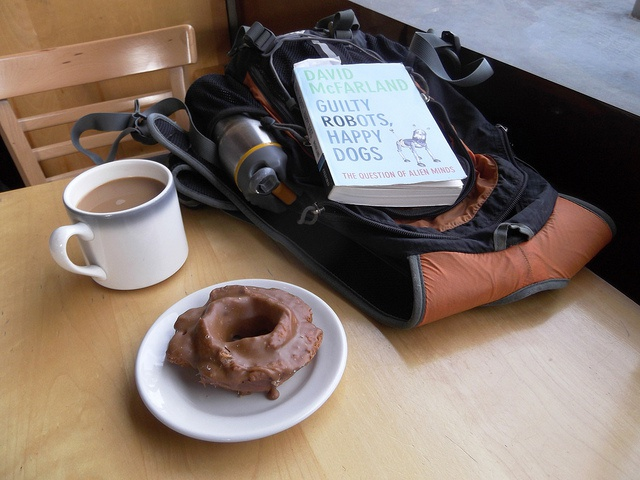Describe the objects in this image and their specific colors. I can see dining table in olive, lightgray, tan, gray, and darkgray tones, backpack in olive, black, brown, gray, and maroon tones, book in olive, lightblue, and darkgray tones, chair in olive, gray, tan, maroon, and brown tones, and cup in olive, lightgray, darkgray, and gray tones in this image. 